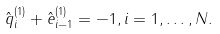<formula> <loc_0><loc_0><loc_500><loc_500>\hat { q } _ { i } ^ { ( 1 ) } + \hat { e } _ { i - 1 } ^ { ( 1 ) } = - 1 , i = 1 , \dots , N .</formula> 